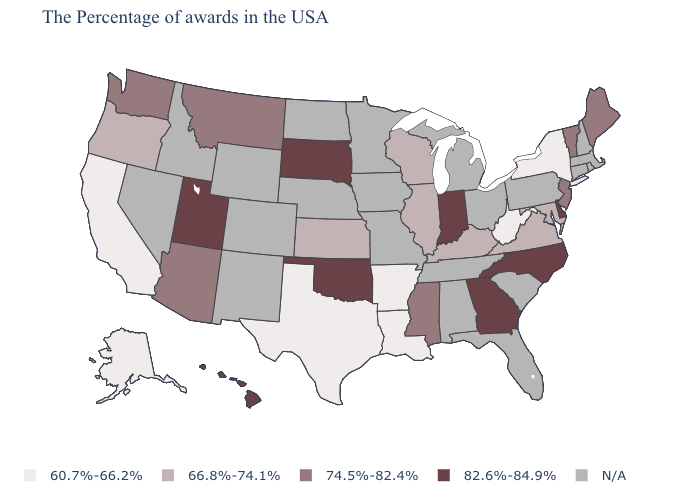Which states have the lowest value in the MidWest?
Give a very brief answer. Wisconsin, Illinois, Kansas. What is the highest value in the USA?
Keep it brief. 82.6%-84.9%. What is the highest value in states that border Georgia?
Concise answer only. 82.6%-84.9%. What is the value of Maine?
Short answer required. 74.5%-82.4%. What is the value of Washington?
Quick response, please. 74.5%-82.4%. Which states have the highest value in the USA?
Write a very short answer. Delaware, North Carolina, Georgia, Indiana, Oklahoma, South Dakota, Utah, Hawaii. What is the highest value in the USA?
Answer briefly. 82.6%-84.9%. Which states have the lowest value in the USA?
Write a very short answer. New York, West Virginia, Louisiana, Arkansas, Texas, California, Alaska. Name the states that have a value in the range N/A?
Short answer required. Massachusetts, Rhode Island, New Hampshire, Connecticut, Pennsylvania, South Carolina, Ohio, Florida, Michigan, Alabama, Tennessee, Missouri, Minnesota, Iowa, Nebraska, North Dakota, Wyoming, Colorado, New Mexico, Idaho, Nevada. What is the value of Colorado?
Concise answer only. N/A. What is the value of New Mexico?
Give a very brief answer. N/A. What is the highest value in the Northeast ?
Keep it brief. 74.5%-82.4%. What is the highest value in the Northeast ?
Give a very brief answer. 74.5%-82.4%. How many symbols are there in the legend?
Answer briefly. 5. 